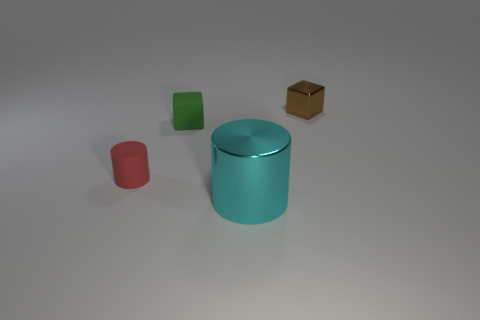There is a tiny thing that is on the right side of the small green rubber thing that is in front of the small brown metal block; what color is it?
Keep it short and to the point. Brown. What is the shape of the green thing that is the same size as the brown metal block?
Keep it short and to the point. Cube. Are there an equal number of metallic cubes that are in front of the small metallic object and tiny metal blocks?
Offer a terse response. No. There is a small object that is to the left of the tiny block that is in front of the shiny thing behind the small rubber cylinder; what is it made of?
Provide a succinct answer. Rubber. What shape is the large thing that is the same material as the small brown block?
Your answer should be very brief. Cylinder. Is there anything else that has the same color as the big metallic cylinder?
Ensure brevity in your answer.  No. How many large cyan metal objects are in front of the shiny object that is in front of the red cylinder that is in front of the green rubber thing?
Your answer should be very brief. 0. What number of brown objects are either tiny metallic cubes or small rubber balls?
Offer a very short reply. 1. Do the brown cube and the cylinder that is behind the cyan metallic cylinder have the same size?
Make the answer very short. Yes. There is another small object that is the same shape as the small shiny object; what is its material?
Give a very brief answer. Rubber. 